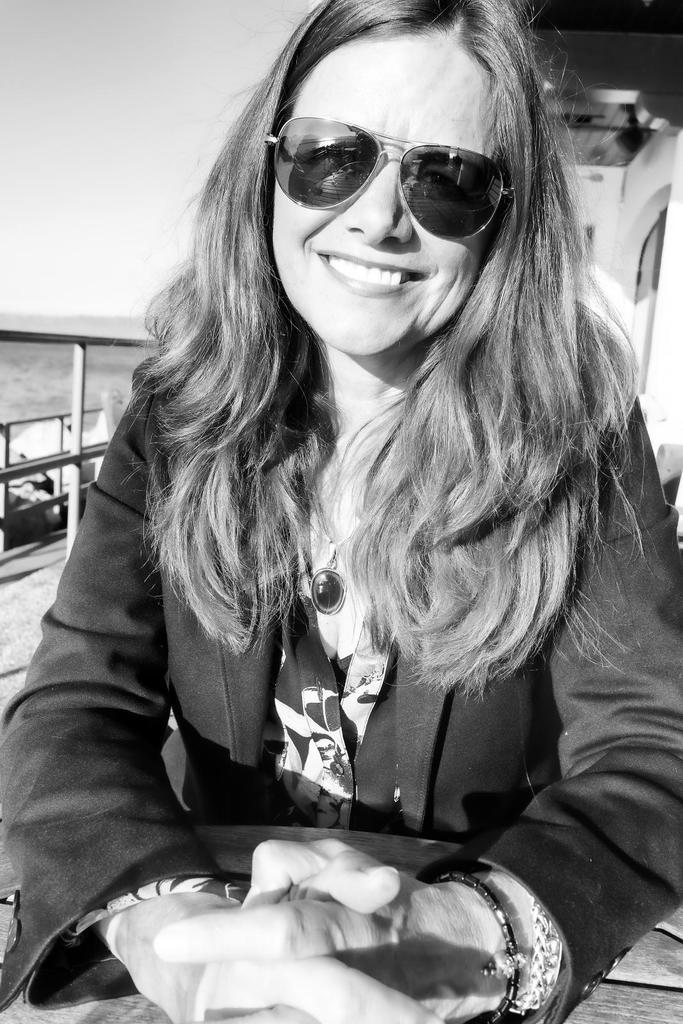Who is the main subject in the image? There is a lady in the image. Where is the lady positioned in the image? The lady is sitting at the center of the image. What accessory is the lady wearing? The lady is wearing sunglasses. What architectural feature can be seen at the left side of the image? There is a staircase at the left side of the image. What type of flight can be seen in the image? There is no flight present in the image; it features a lady sitting at the center of the image. How does the lady crush the objects in the image? The lady is not shown crushing any objects in the image. 